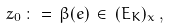<formula> <loc_0><loc_0><loc_500><loc_500>z _ { 0 } \, \colon = \, \beta ( e ) \, \in \, ( E _ { K } ) _ { x } \, ,</formula> 